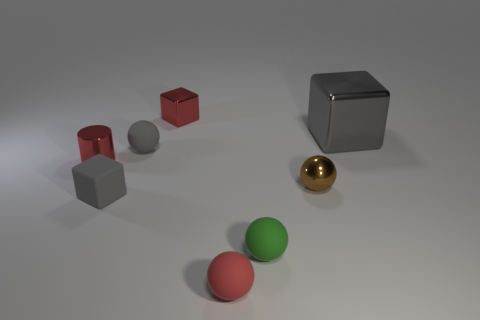Subtract all tiny shiny spheres. How many spheres are left? 3 Add 1 yellow rubber spheres. How many objects exist? 9 Subtract all gray spheres. How many spheres are left? 3 Subtract all blocks. How many objects are left? 5 Subtract all purple spheres. How many gray cubes are left? 2 Subtract all green spheres. Subtract all tiny blocks. How many objects are left? 5 Add 8 tiny brown shiny balls. How many tiny brown shiny balls are left? 9 Add 4 large gray shiny cubes. How many large gray shiny cubes exist? 5 Subtract 0 cyan cylinders. How many objects are left? 8 Subtract all cyan balls. Subtract all cyan cylinders. How many balls are left? 4 